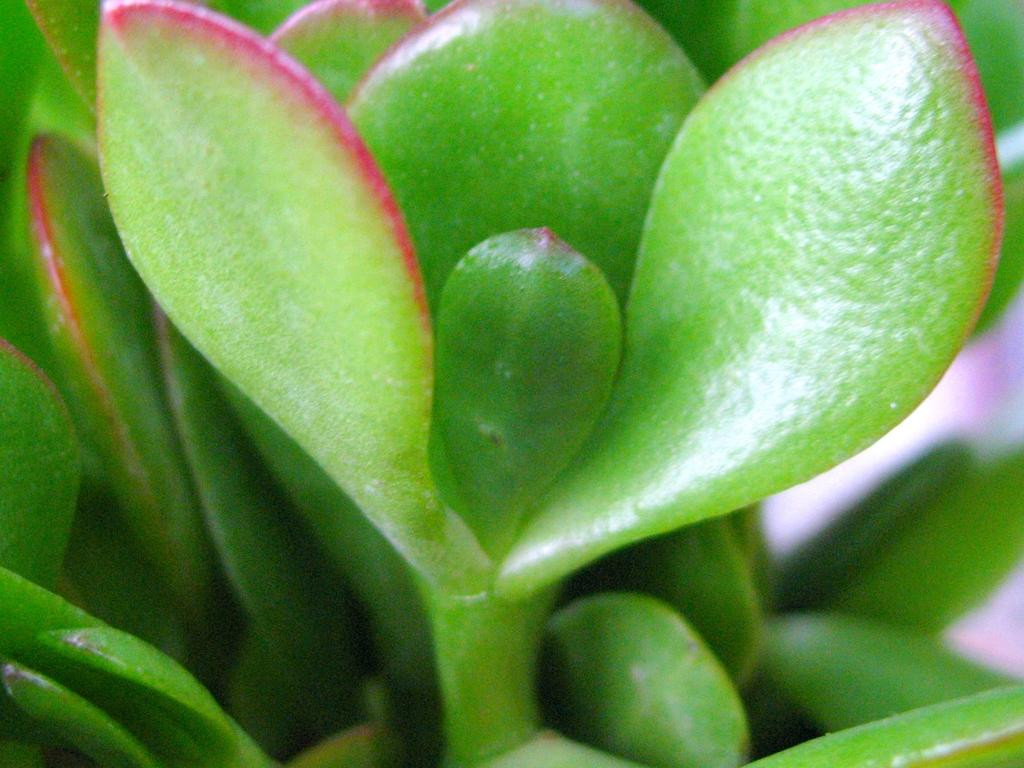What type of plant material can be seen in the image? There are leaves in the image. What part of the plant is connected to the leaves in the image? There is a stem in the image. What type of meat is being served on the donkey in the image? There is no donkey or meat present in the image; it only features leaves and a stem. 